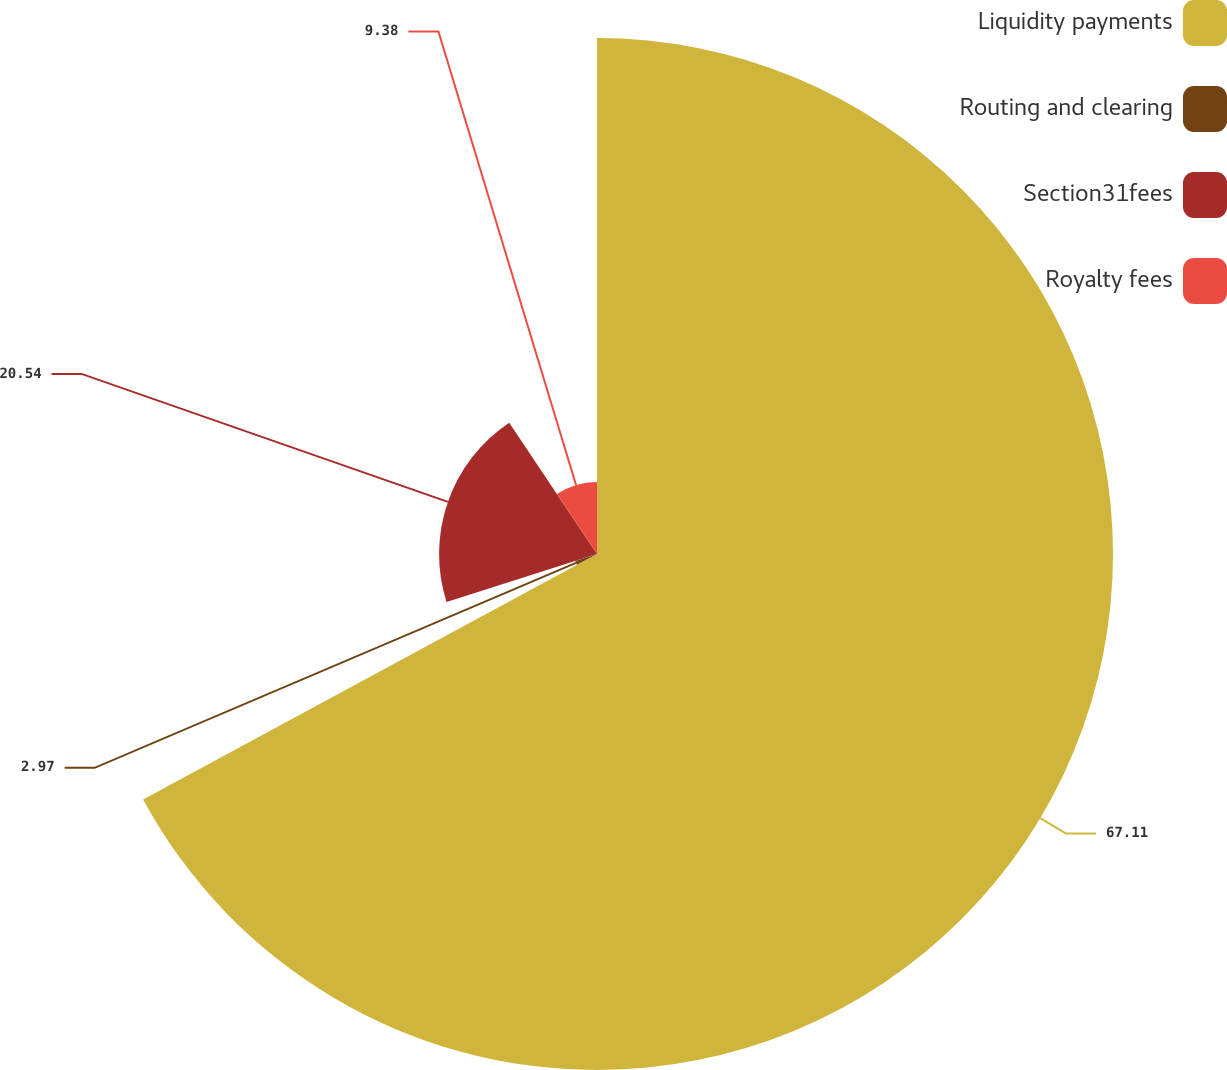Convert chart. <chart><loc_0><loc_0><loc_500><loc_500><pie_chart><fcel>Liquidity payments<fcel>Routing and clearing<fcel>Section31fees<fcel>Royalty fees<nl><fcel>67.11%<fcel>2.97%<fcel>20.54%<fcel>9.38%<nl></chart> 